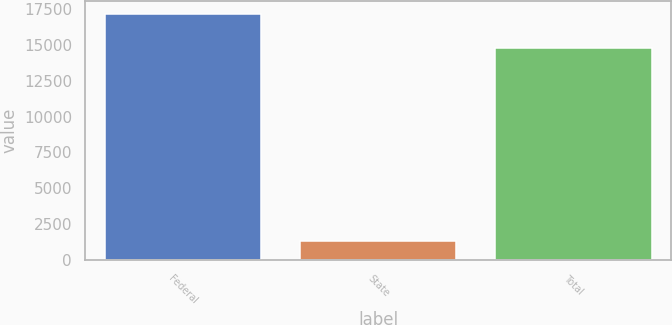Convert chart. <chart><loc_0><loc_0><loc_500><loc_500><bar_chart><fcel>Federal<fcel>State<fcel>Total<nl><fcel>17200<fcel>1310<fcel>14816<nl></chart> 